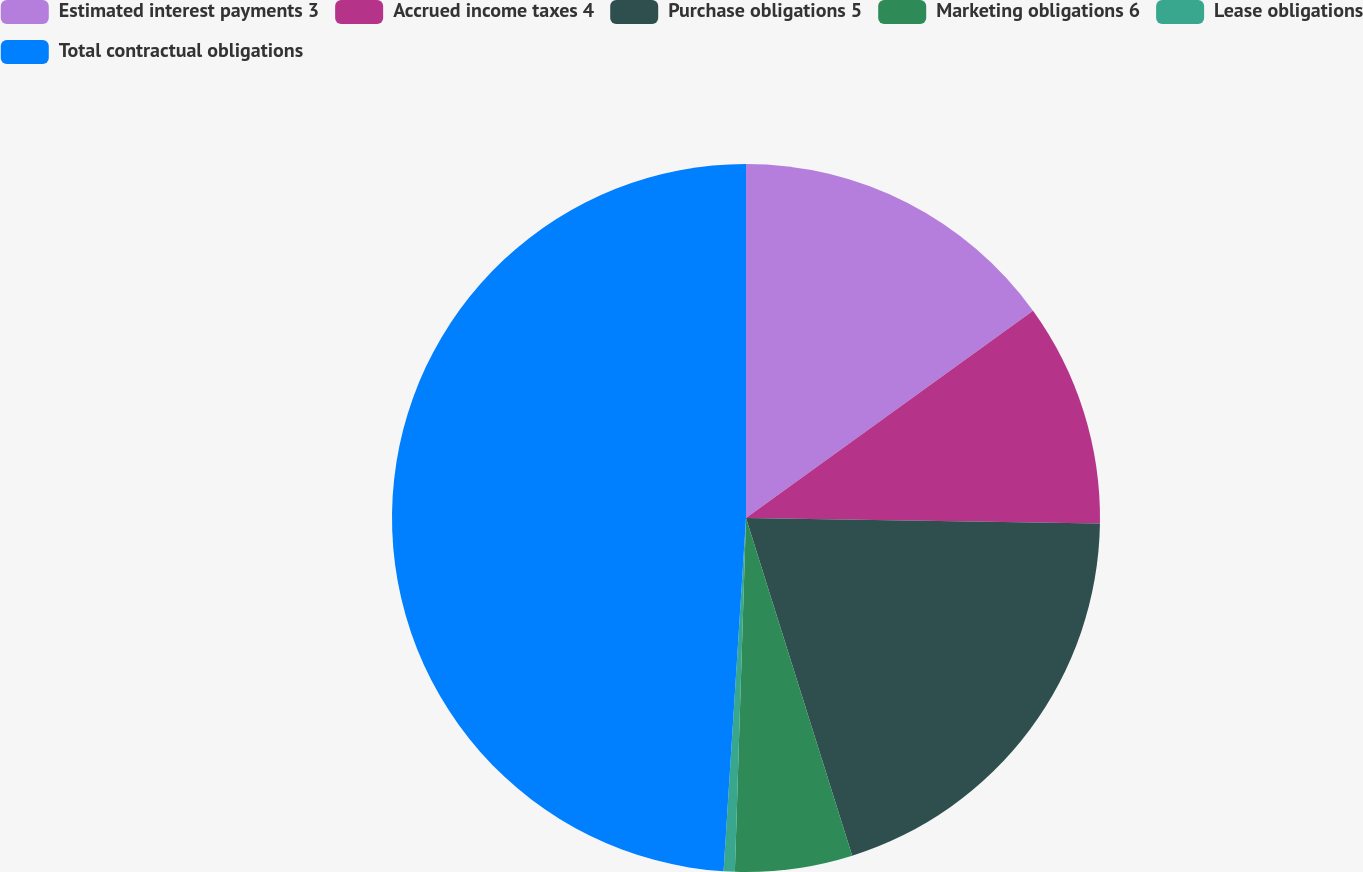Convert chart. <chart><loc_0><loc_0><loc_500><loc_500><pie_chart><fcel>Estimated interest payments 3<fcel>Accrued income taxes 4<fcel>Purchase obligations 5<fcel>Marketing obligations 6<fcel>Lease obligations<fcel>Total contractual obligations<nl><fcel>15.05%<fcel>10.2%<fcel>19.9%<fcel>5.35%<fcel>0.51%<fcel>48.99%<nl></chart> 